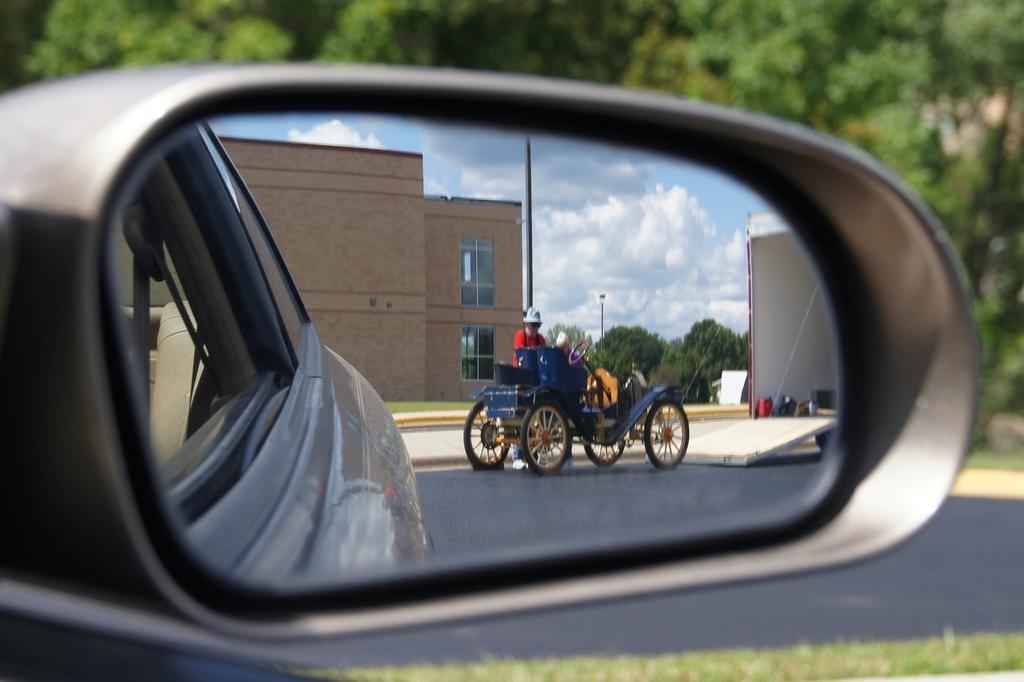In one or two sentences, can you explain what this image depicts? In this image I can see a mirror of a vehicle and in this mirror I can see reflection of a vehicle, a person and of a building. I can also see number of trees, clouds and the sky. I can also see this image is little bit blurry from background. 